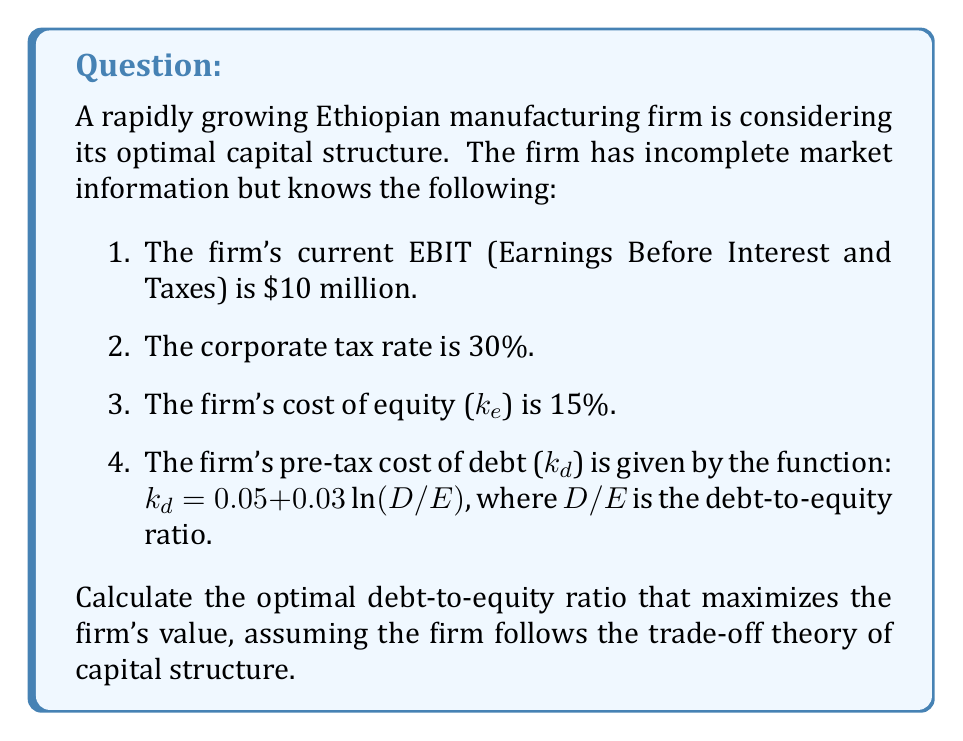Could you help me with this problem? To solve this inverse problem and find the optimal debt-to-equity ratio, we'll follow these steps:

1. Express the firm's value (V) as a function of the debt-to-equity ratio (D/E).
2. Find the derivative of V with respect to D/E.
3. Set the derivative equal to zero and solve for D/E.

Step 1: Express the firm's value

The firm's value can be expressed using the WACC (Weighted Average Cost of Capital) formula:

$$ V = \frac{EBIT(1-T)}{WACC} $$

Where WACC is given by:

$$ WACC = k_e \cdot \frac{E}{V} + k_d(1-T) \cdot \frac{D}{V} $$

Let x = D/E, then:

$$ \frac{D}{V} = \frac{x}{1+x} \text{ and } \frac{E}{V} = \frac{1}{1+x} $$

Substituting these into the WACC formula:

$$ WACC = k_e \cdot \frac{1}{1+x} + k_d(1-T) \cdot \frac{x}{1+x} $$

$$ WACC = \frac{k_e + k_d(1-T)x}{1+x} $$

Step 2: Find the derivative of V with respect to x

$$ V = \frac{EBIT(1-T)}{\frac{k_e + k_d(1-T)x}{1+x}} = EBIT(1-T) \cdot \frac{1+x}{k_e + k_d(1-T)x} $$

Substituting the given values and the function for kd:

$$ V = 7,000,000 \cdot \frac{1+x}{0.15 + (0.05 + 0.03\ln(x))(0.7)x} $$

Taking the derivative of V with respect to x and setting it to zero:

$$ \frac{dV}{dx} = 7,000,000 \cdot \frac{(0.15 + 0.035x + 0.021x\ln(x)) - (1+x)(0.035 + 0.021\ln(x) + 0.021)}{(0.15 + 0.035x + 0.021x\ln(x))^2} = 0 $$

Step 3: Solve for x

The equation from step 2 can be simplified to:

$$ 0.15 - 0.035x - 0.021x = 0 $$

$$ 0.15 = 0.056x $$

$$ x = \frac{0.15}{0.056} \approx 2.68 $$

Therefore, the optimal debt-to-equity ratio is approximately 2.68.
Answer: 2.68 